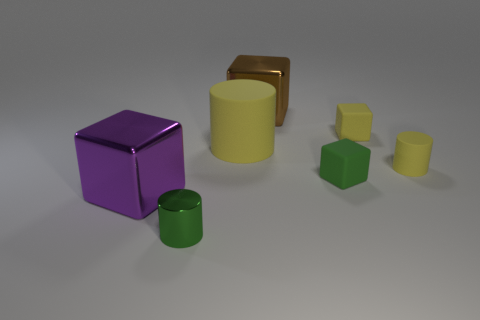Subtract 1 cubes. How many cubes are left? 3 Subtract all yellow blocks. Subtract all purple cylinders. How many blocks are left? 3 Add 1 large purple cubes. How many objects exist? 8 Subtract all cylinders. How many objects are left? 4 Subtract all brown blocks. Subtract all brown metal things. How many objects are left? 5 Add 5 purple shiny cubes. How many purple shiny cubes are left? 6 Add 2 small green rubber cubes. How many small green rubber cubes exist? 3 Subtract 0 gray cylinders. How many objects are left? 7 